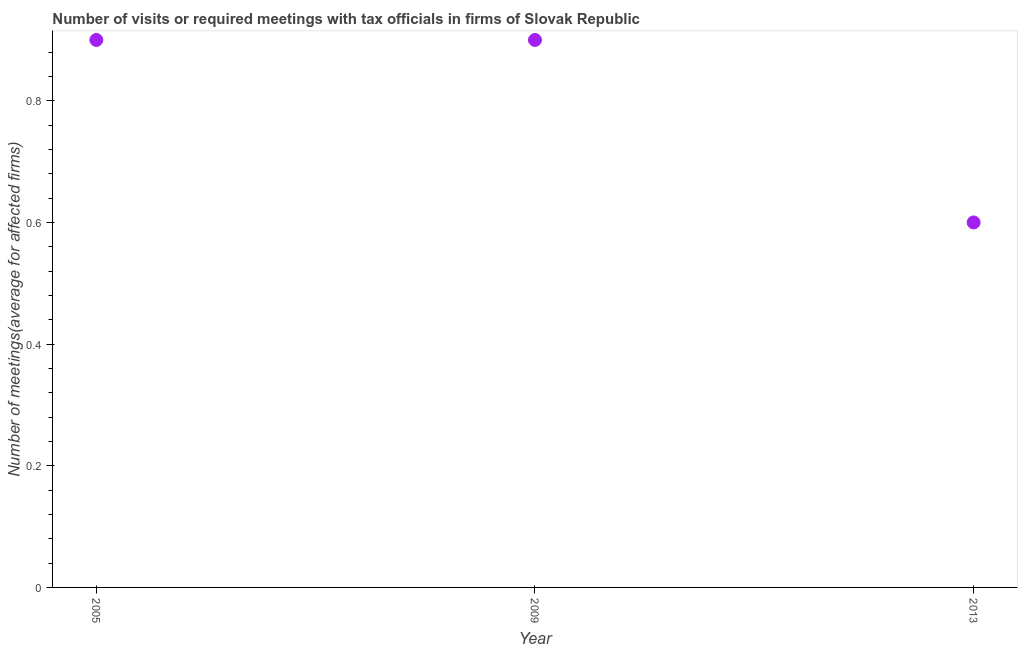What is the number of required meetings with tax officials in 2009?
Your answer should be compact. 0.9. Across all years, what is the maximum number of required meetings with tax officials?
Ensure brevity in your answer.  0.9. In which year was the number of required meetings with tax officials maximum?
Keep it short and to the point. 2005. What is the sum of the number of required meetings with tax officials?
Your answer should be very brief. 2.4. What is the difference between the number of required meetings with tax officials in 2005 and 2009?
Your answer should be very brief. 0. What is the average number of required meetings with tax officials per year?
Your answer should be very brief. 0.8. In how many years, is the number of required meetings with tax officials greater than 0.32 ?
Make the answer very short. 3. What is the ratio of the number of required meetings with tax officials in 2005 to that in 2009?
Offer a terse response. 1. Is the number of required meetings with tax officials in 2005 less than that in 2013?
Offer a very short reply. No. What is the difference between the highest and the second highest number of required meetings with tax officials?
Ensure brevity in your answer.  0. What is the difference between the highest and the lowest number of required meetings with tax officials?
Offer a very short reply. 0.3. Does the number of required meetings with tax officials monotonically increase over the years?
Your answer should be compact. No. How many years are there in the graph?
Ensure brevity in your answer.  3. Are the values on the major ticks of Y-axis written in scientific E-notation?
Give a very brief answer. No. Does the graph contain any zero values?
Provide a succinct answer. No. Does the graph contain grids?
Offer a very short reply. No. What is the title of the graph?
Keep it short and to the point. Number of visits or required meetings with tax officials in firms of Slovak Republic. What is the label or title of the Y-axis?
Your answer should be very brief. Number of meetings(average for affected firms). What is the Number of meetings(average for affected firms) in 2005?
Your answer should be compact. 0.9. What is the Number of meetings(average for affected firms) in 2009?
Your response must be concise. 0.9. What is the Number of meetings(average for affected firms) in 2013?
Give a very brief answer. 0.6. What is the difference between the Number of meetings(average for affected firms) in 2005 and 2009?
Provide a short and direct response. 0. What is the difference between the Number of meetings(average for affected firms) in 2009 and 2013?
Your answer should be compact. 0.3. What is the ratio of the Number of meetings(average for affected firms) in 2005 to that in 2009?
Offer a terse response. 1. What is the ratio of the Number of meetings(average for affected firms) in 2005 to that in 2013?
Offer a terse response. 1.5. 